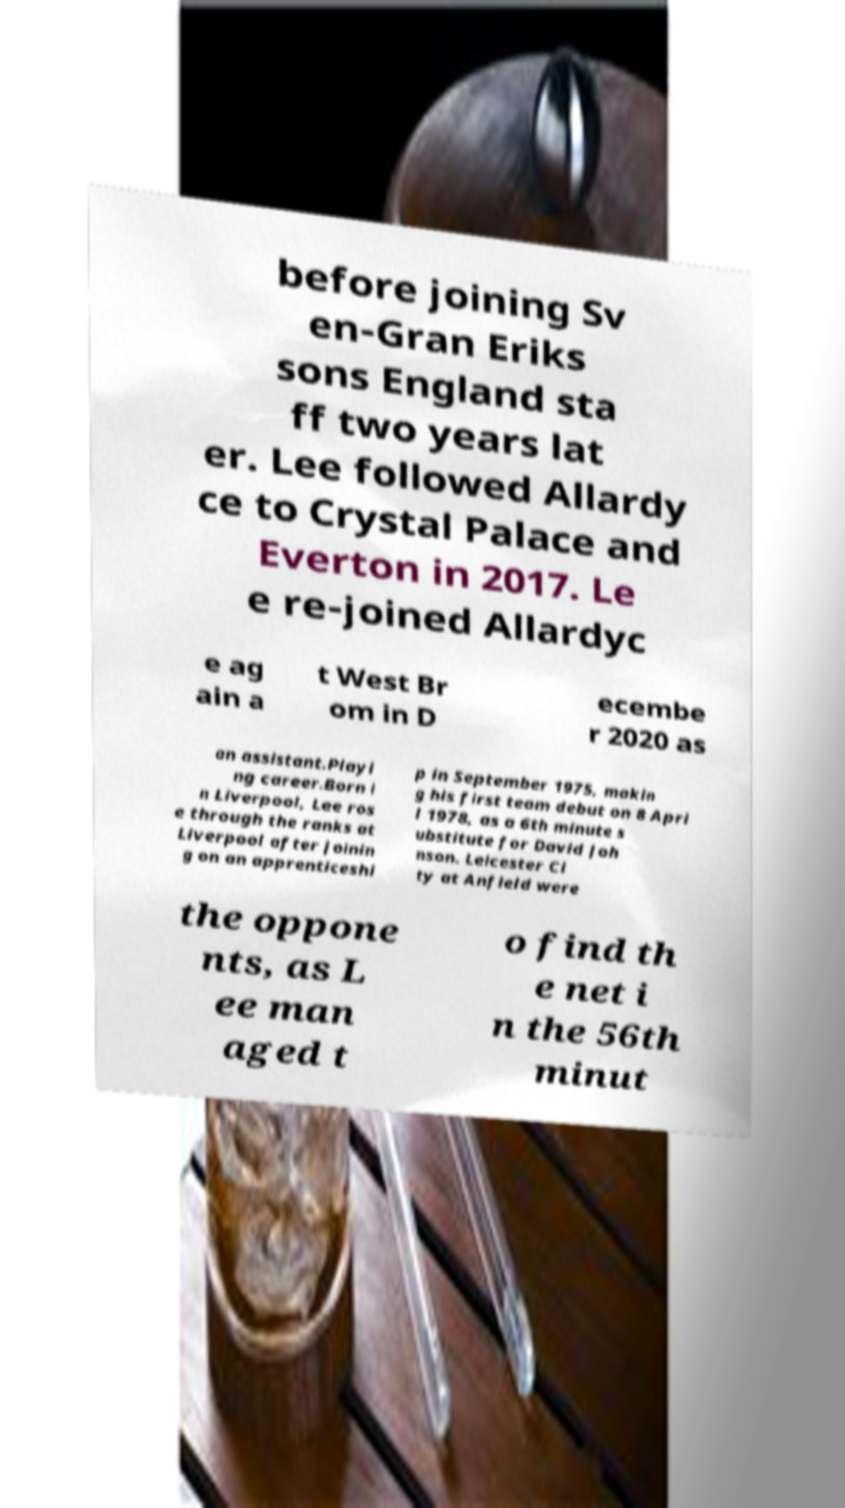Could you assist in decoding the text presented in this image and type it out clearly? before joining Sv en-Gran Eriks sons England sta ff two years lat er. Lee followed Allardy ce to Crystal Palace and Everton in 2017. Le e re-joined Allardyc e ag ain a t West Br om in D ecembe r 2020 as an assistant.Playi ng career.Born i n Liverpool, Lee ros e through the ranks at Liverpool after joinin g on an apprenticeshi p in September 1975, makin g his first team debut on 8 Apri l 1978, as a 6th minute s ubstitute for David Joh nson. Leicester Ci ty at Anfield were the oppone nts, as L ee man aged t o find th e net i n the 56th minut 